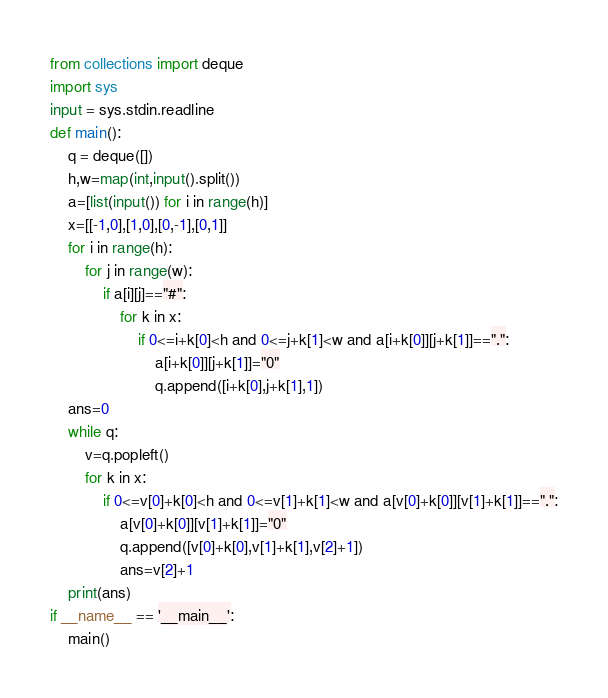<code> <loc_0><loc_0><loc_500><loc_500><_Python_>from collections import deque 
import sys
input = sys.stdin.readline
def main():
    q = deque([])
    h,w=map(int,input().split())
    a=[list(input()) for i in range(h)]
    x=[[-1,0],[1,0],[0,-1],[0,1]]
    for i in range(h):
        for j in range(w):
            if a[i][j]=="#":
                for k in x:
                    if 0<=i+k[0]<h and 0<=j+k[1]<w and a[i+k[0]][j+k[1]]==".":
                        a[i+k[0]][j+k[1]]="0"
                        q.append([i+k[0],j+k[1],1])
    ans=0
    while q:
        v=q.popleft()
        for k in x:
            if 0<=v[0]+k[0]<h and 0<=v[1]+k[1]<w and a[v[0]+k[0]][v[1]+k[1]]==".":
                a[v[0]+k[0]][v[1]+k[1]]="0"
                q.append([v[0]+k[0],v[1]+k[1],v[2]+1])
                ans=v[2]+1
    print(ans)
if __name__ == '__main__':
    main()
</code> 